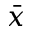Convert formula to latex. <formula><loc_0><loc_0><loc_500><loc_500>\ B a r { x }</formula> 